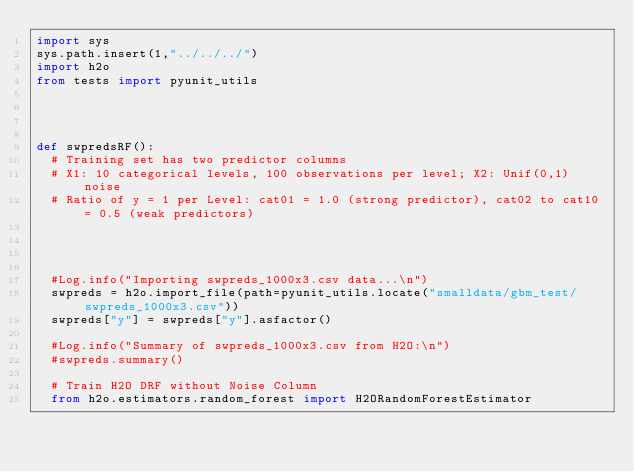<code> <loc_0><loc_0><loc_500><loc_500><_Python_>import sys
sys.path.insert(1,"../../../")
import h2o
from tests import pyunit_utils




def swpredsRF():
  # Training set has two predictor columns
  # X1: 10 categorical levels, 100 observations per level; X2: Unif(0,1) noise
  # Ratio of y = 1 per Level: cat01 = 1.0 (strong predictor), cat02 to cat10 = 0.5 (weak predictors)




  #Log.info("Importing swpreds_1000x3.csv data...\n")
  swpreds = h2o.import_file(path=pyunit_utils.locate("smalldata/gbm_test/swpreds_1000x3.csv"))
  swpreds["y"] = swpreds["y"].asfactor()

  #Log.info("Summary of swpreds_1000x3.csv from H2O:\n")
  #swpreds.summary()

  # Train H2O DRF without Noise Column
  from h2o.estimators.random_forest import H2ORandomForestEstimator
</code> 